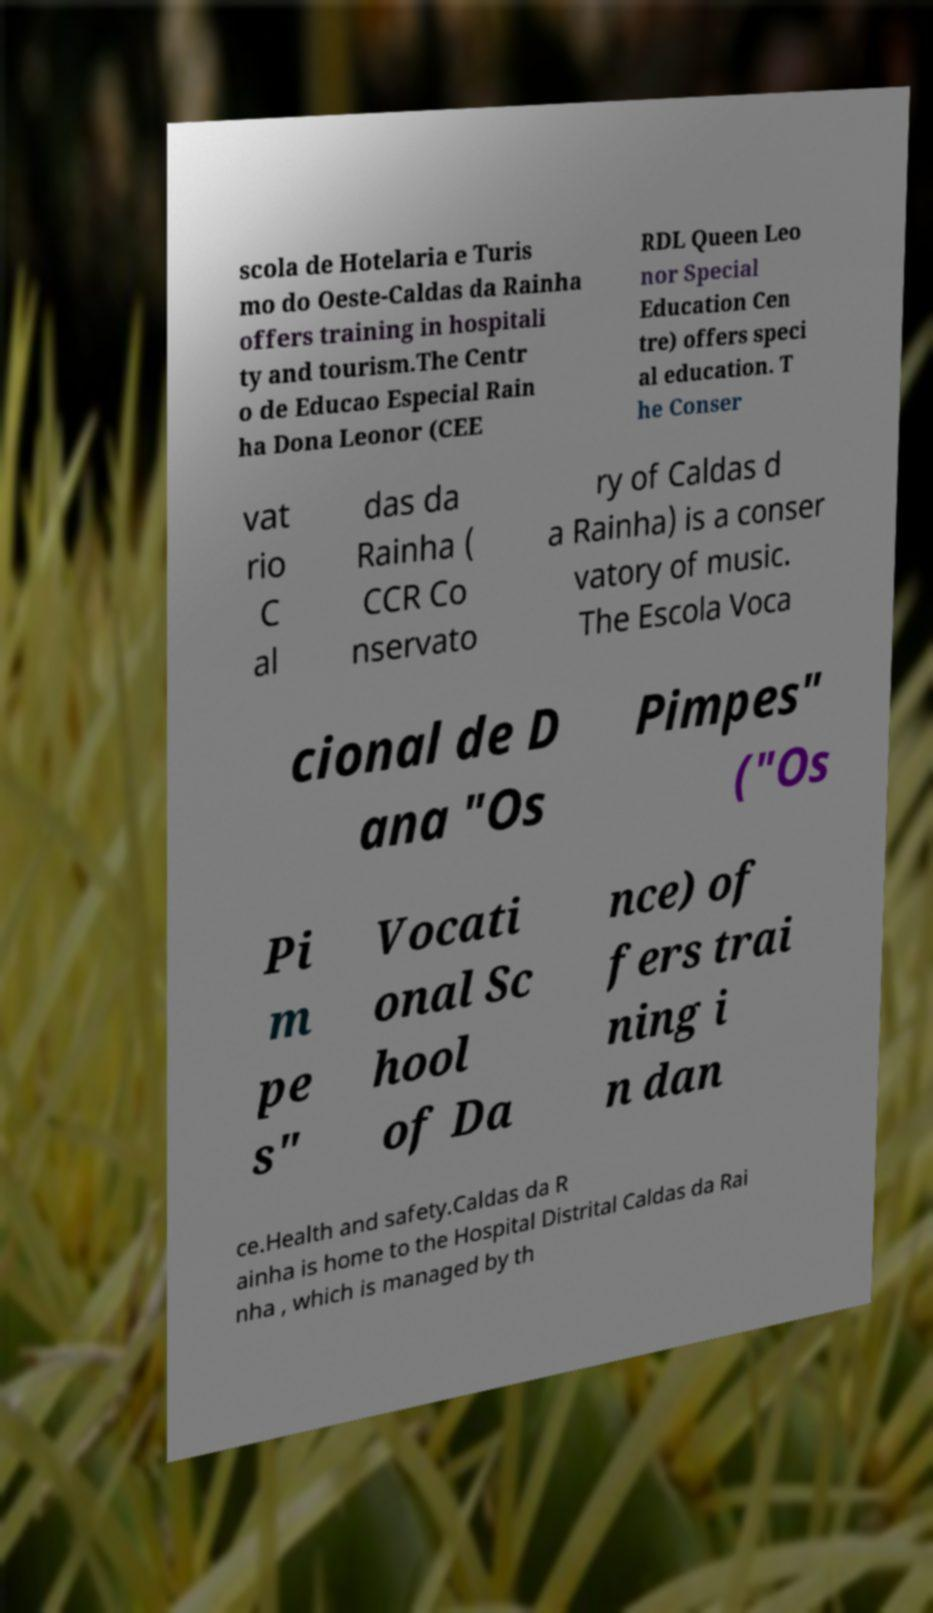For documentation purposes, I need the text within this image transcribed. Could you provide that? scola de Hotelaria e Turis mo do Oeste-Caldas da Rainha offers training in hospitali ty and tourism.The Centr o de Educao Especial Rain ha Dona Leonor (CEE RDL Queen Leo nor Special Education Cen tre) offers speci al education. T he Conser vat rio C al das da Rainha ( CCR Co nservato ry of Caldas d a Rainha) is a conser vatory of music. The Escola Voca cional de D ana "Os Pimpes" ("Os Pi m pe s" Vocati onal Sc hool of Da nce) of fers trai ning i n dan ce.Health and safety.Caldas da R ainha is home to the Hospital Distrital Caldas da Rai nha , which is managed by th 